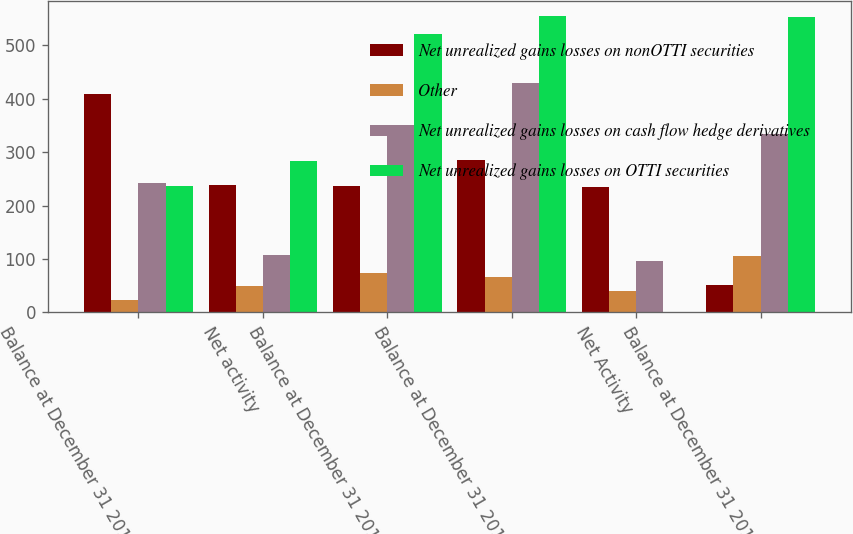Convert chart to OTSL. <chart><loc_0><loc_0><loc_500><loc_500><stacked_bar_chart><ecel><fcel>Balance at December 31 2013<fcel>Net activity<fcel>Balance at December 31 2014<fcel>Balance at December 31 2015<fcel>Net Activity<fcel>Balance at December 31 2016<nl><fcel>Net unrealized gains losses on nonOTTI securities<fcel>409<fcel>238<fcel>237<fcel>286<fcel>234<fcel>52<nl><fcel>Other<fcel>24<fcel>50<fcel>74<fcel>66<fcel>40<fcel>106<nl><fcel>Net unrealized gains losses on cash flow hedge derivatives<fcel>243<fcel>107<fcel>350<fcel>430<fcel>97<fcel>333<nl><fcel>Net unrealized gains losses on OTTI securities<fcel>237<fcel>283<fcel>520<fcel>554<fcel>1<fcel>553<nl></chart> 